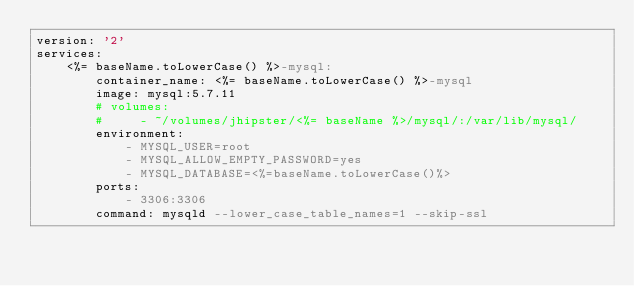<code> <loc_0><loc_0><loc_500><loc_500><_YAML_>version: '2'
services:
    <%= baseName.toLowerCase() %>-mysql:
        container_name: <%= baseName.toLowerCase() %>-mysql
        image: mysql:5.7.11
        # volumes:
        #     - ~/volumes/jhipster/<%= baseName %>/mysql/:/var/lib/mysql/
        environment:
            - MYSQL_USER=root
            - MYSQL_ALLOW_EMPTY_PASSWORD=yes
            - MYSQL_DATABASE=<%=baseName.toLowerCase()%>
        ports:
            - 3306:3306
        command: mysqld --lower_case_table_names=1 --skip-ssl
</code> 